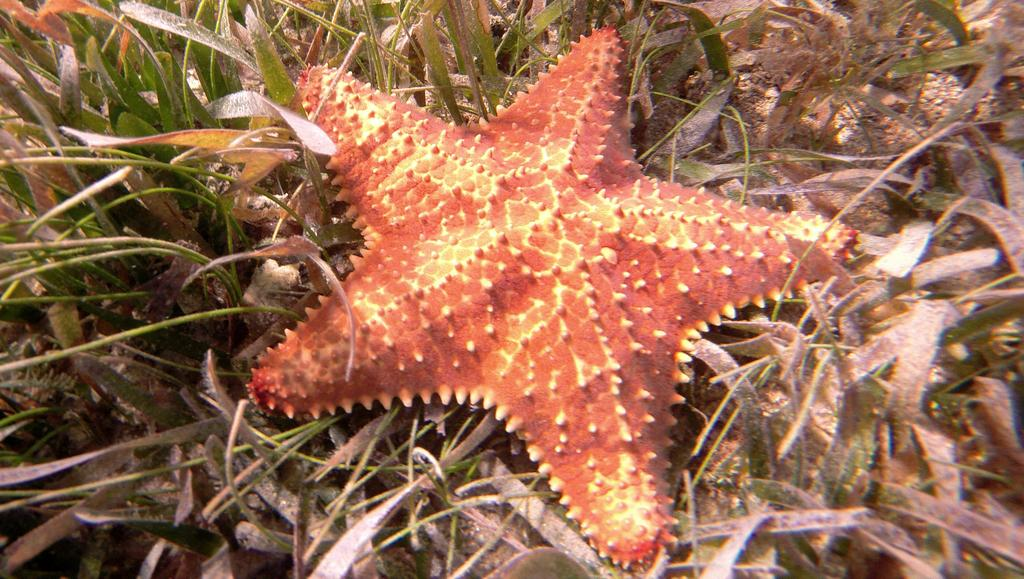What type of sea creature is in the image? There is a starfish in the image. Where is the starfish located? The starfish is on the ground. What type of vegetation is present on the ground in the image? There is grass on the ground in the image. What type of underwear is the starfish wearing in the image? Starfish do not wear underwear, as they are marine animals without the ability to wear clothing. 